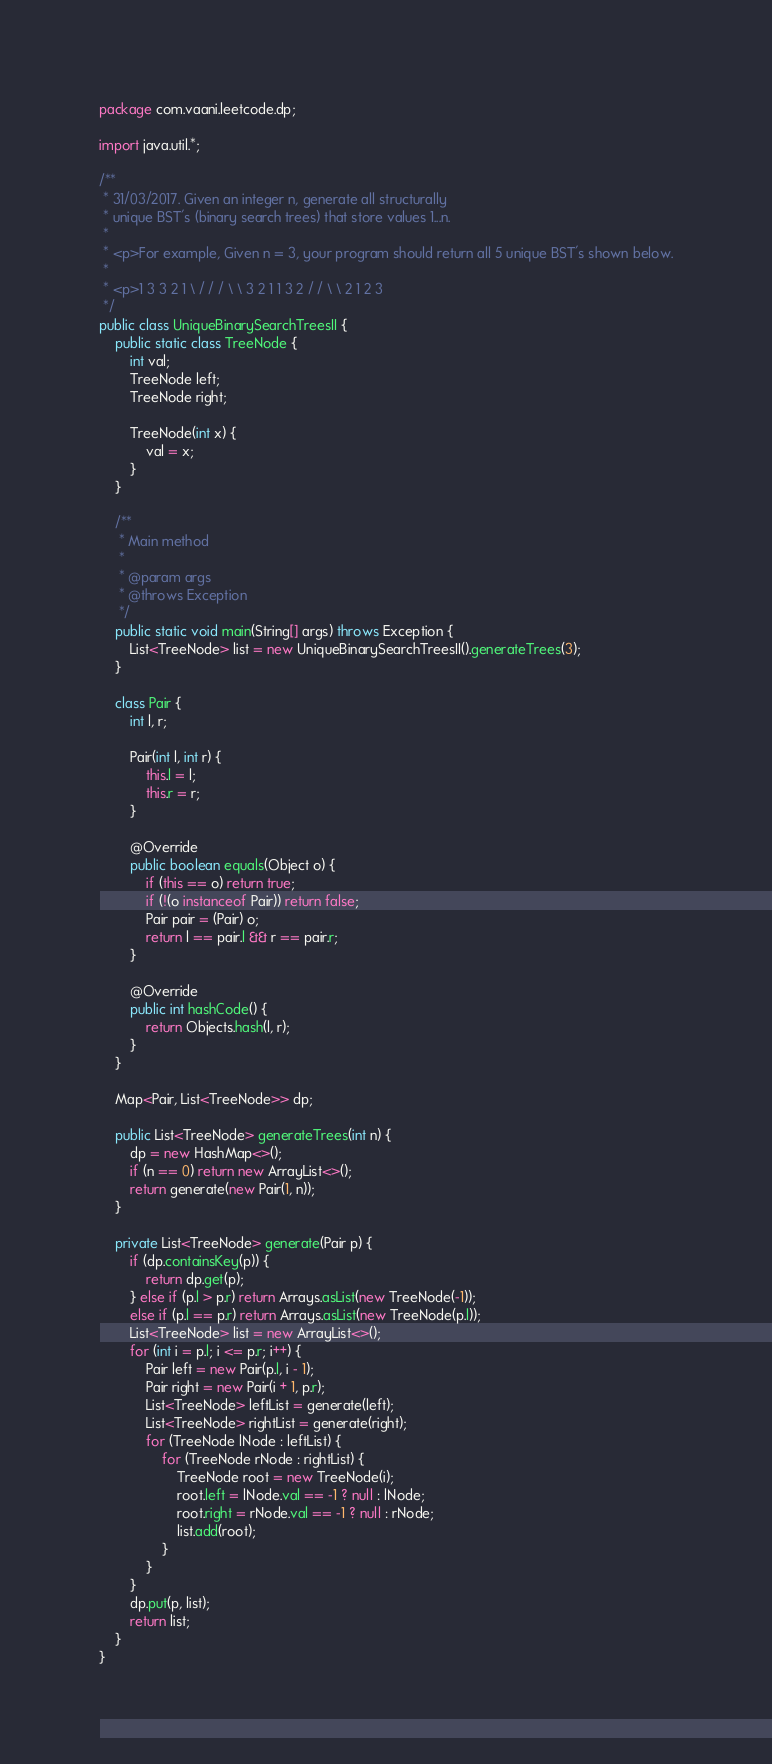Convert code to text. <code><loc_0><loc_0><loc_500><loc_500><_Java_>package com.vaani.leetcode.dp;

import java.util.*;

/**
 * 31/03/2017. Given an integer n, generate all structurally
 * unique BST's (binary search trees) that store values 1...n.
 *
 * <p>For example, Given n = 3, your program should return all 5 unique BST's shown below.
 *
 * <p>1 3 3 2 1 \ / / / \ \ 3 2 1 1 3 2 / / \ \ 2 1 2 3
 */
public class UniqueBinarySearchTreesII {
    public static class TreeNode {
        int val;
        TreeNode left;
        TreeNode right;

        TreeNode(int x) {
            val = x;
        }
    }

    /**
     * Main method
     *
     * @param args
     * @throws Exception
     */
    public static void main(String[] args) throws Exception {
        List<TreeNode> list = new UniqueBinarySearchTreesII().generateTrees(3);
    }

    class Pair {
        int l, r;

        Pair(int l, int r) {
            this.l = l;
            this.r = r;
        }

        @Override
        public boolean equals(Object o) {
            if (this == o) return true;
            if (!(o instanceof Pair)) return false;
            Pair pair = (Pair) o;
            return l == pair.l && r == pair.r;
        }

        @Override
        public int hashCode() {
            return Objects.hash(l, r);
        }
    }

    Map<Pair, List<TreeNode>> dp;

    public List<TreeNode> generateTrees(int n) {
        dp = new HashMap<>();
        if (n == 0) return new ArrayList<>();
        return generate(new Pair(1, n));
    }

    private List<TreeNode> generate(Pair p) {
        if (dp.containsKey(p)) {
            return dp.get(p);
        } else if (p.l > p.r) return Arrays.asList(new TreeNode(-1));
        else if (p.l == p.r) return Arrays.asList(new TreeNode(p.l));
        List<TreeNode> list = new ArrayList<>();
        for (int i = p.l; i <= p.r; i++) {
            Pair left = new Pair(p.l, i - 1);
            Pair right = new Pair(i + 1, p.r);
            List<TreeNode> leftList = generate(left);
            List<TreeNode> rightList = generate(right);
            for (TreeNode lNode : leftList) {
                for (TreeNode rNode : rightList) {
                    TreeNode root = new TreeNode(i);
                    root.left = lNode.val == -1 ? null : lNode;
                    root.right = rNode.val == -1 ? null : rNode;
                    list.add(root);
                }
            }
        }
        dp.put(p, list);
        return list;
    }
}
</code> 